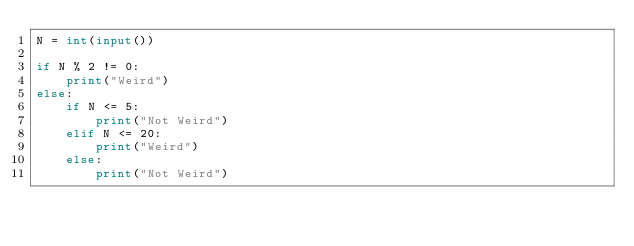<code> <loc_0><loc_0><loc_500><loc_500><_Python_>N = int(input())

if N % 2 != 0:
    print("Weird")
else:
    if N <= 5:
        print("Not Weird")
    elif N <= 20:
        print("Weird")
    else:
        print("Not Weird")
</code> 